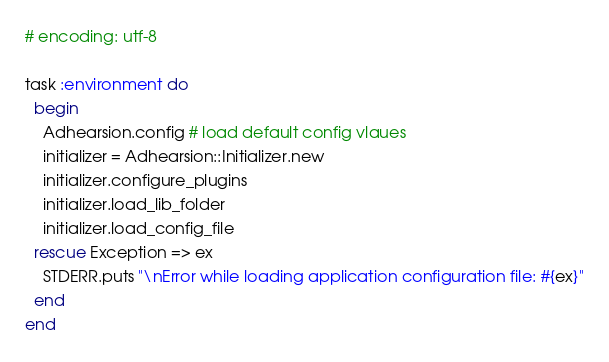<code> <loc_0><loc_0><loc_500><loc_500><_Ruby_># encoding: utf-8

task :environment do
  begin
    Adhearsion.config # load default config vlaues
    initializer = Adhearsion::Initializer.new
    initializer.configure_plugins
    initializer.load_lib_folder
    initializer.load_config_file
  rescue Exception => ex
    STDERR.puts "\nError while loading application configuration file: #{ex}"
  end
end
</code> 